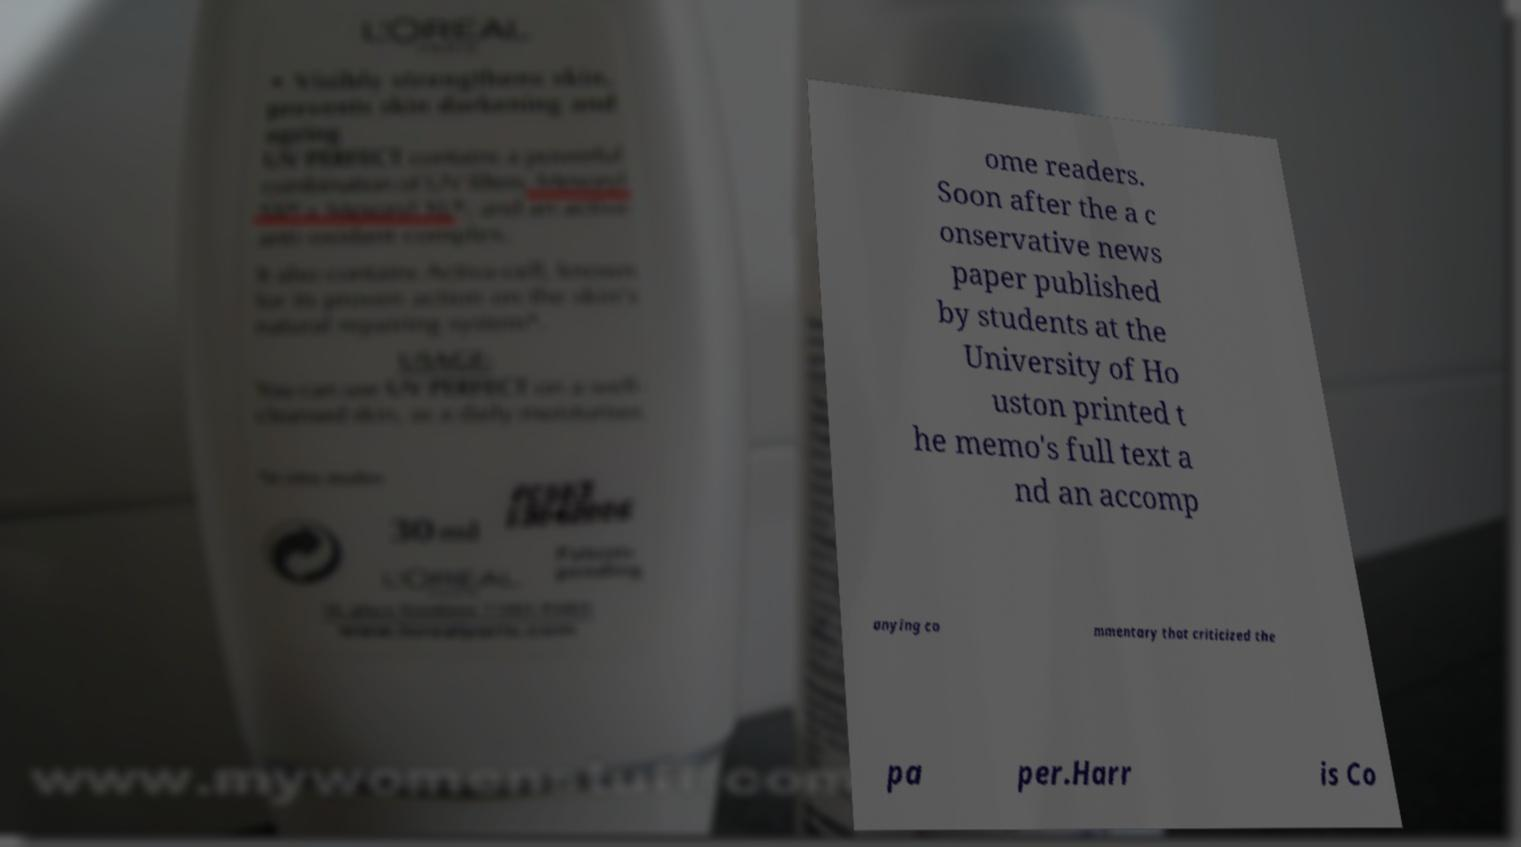Can you accurately transcribe the text from the provided image for me? ome readers. Soon after the a c onservative news paper published by students at the University of Ho uston printed t he memo's full text a nd an accomp anying co mmentary that criticized the pa per.Harr is Co 